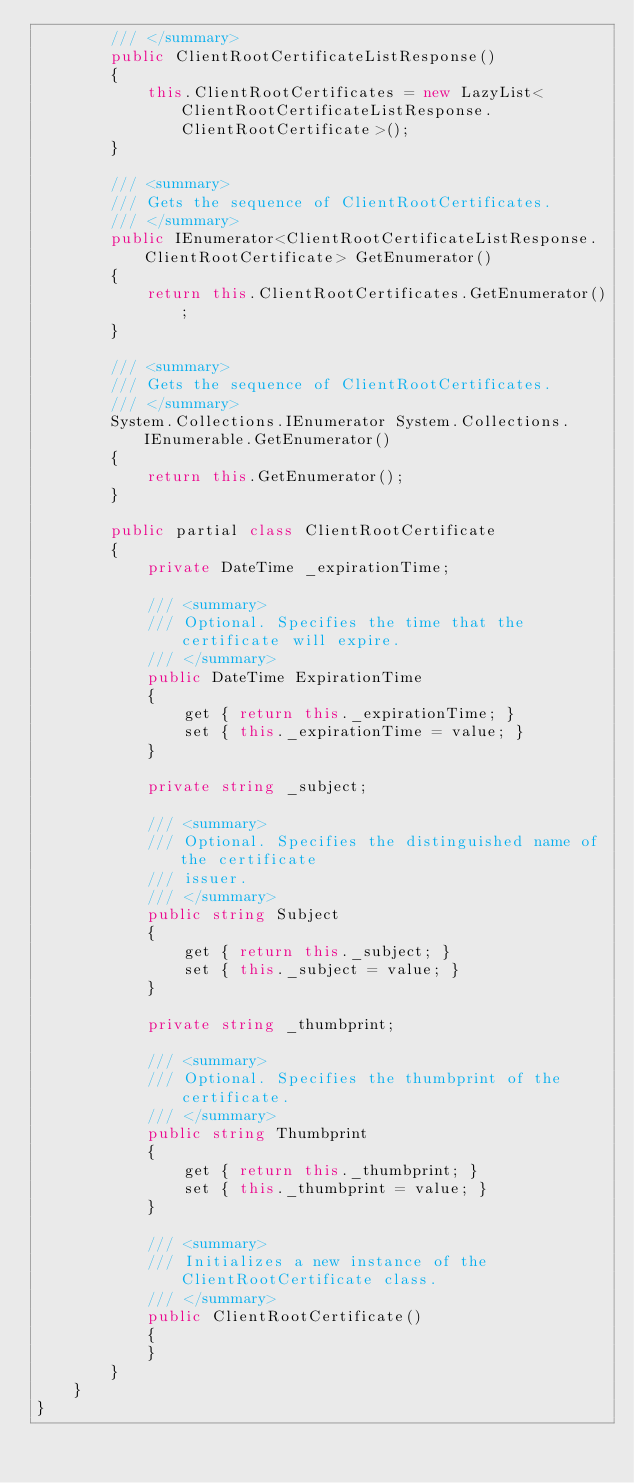Convert code to text. <code><loc_0><loc_0><loc_500><loc_500><_C#_>        /// </summary>
        public ClientRootCertificateListResponse()
        {
            this.ClientRootCertificates = new LazyList<ClientRootCertificateListResponse.ClientRootCertificate>();
        }
        
        /// <summary>
        /// Gets the sequence of ClientRootCertificates.
        /// </summary>
        public IEnumerator<ClientRootCertificateListResponse.ClientRootCertificate> GetEnumerator()
        {
            return this.ClientRootCertificates.GetEnumerator();
        }
        
        /// <summary>
        /// Gets the sequence of ClientRootCertificates.
        /// </summary>
        System.Collections.IEnumerator System.Collections.IEnumerable.GetEnumerator()
        {
            return this.GetEnumerator();
        }
        
        public partial class ClientRootCertificate
        {
            private DateTime _expirationTime;
            
            /// <summary>
            /// Optional. Specifies the time that the certificate will expire.
            /// </summary>
            public DateTime ExpirationTime
            {
                get { return this._expirationTime; }
                set { this._expirationTime = value; }
            }
            
            private string _subject;
            
            /// <summary>
            /// Optional. Specifies the distinguished name of the certificate
            /// issuer.
            /// </summary>
            public string Subject
            {
                get { return this._subject; }
                set { this._subject = value; }
            }
            
            private string _thumbprint;
            
            /// <summary>
            /// Optional. Specifies the thumbprint of the certificate.
            /// </summary>
            public string Thumbprint
            {
                get { return this._thumbprint; }
                set { this._thumbprint = value; }
            }
            
            /// <summary>
            /// Initializes a new instance of the ClientRootCertificate class.
            /// </summary>
            public ClientRootCertificate()
            {
            }
        }
    }
}
</code> 